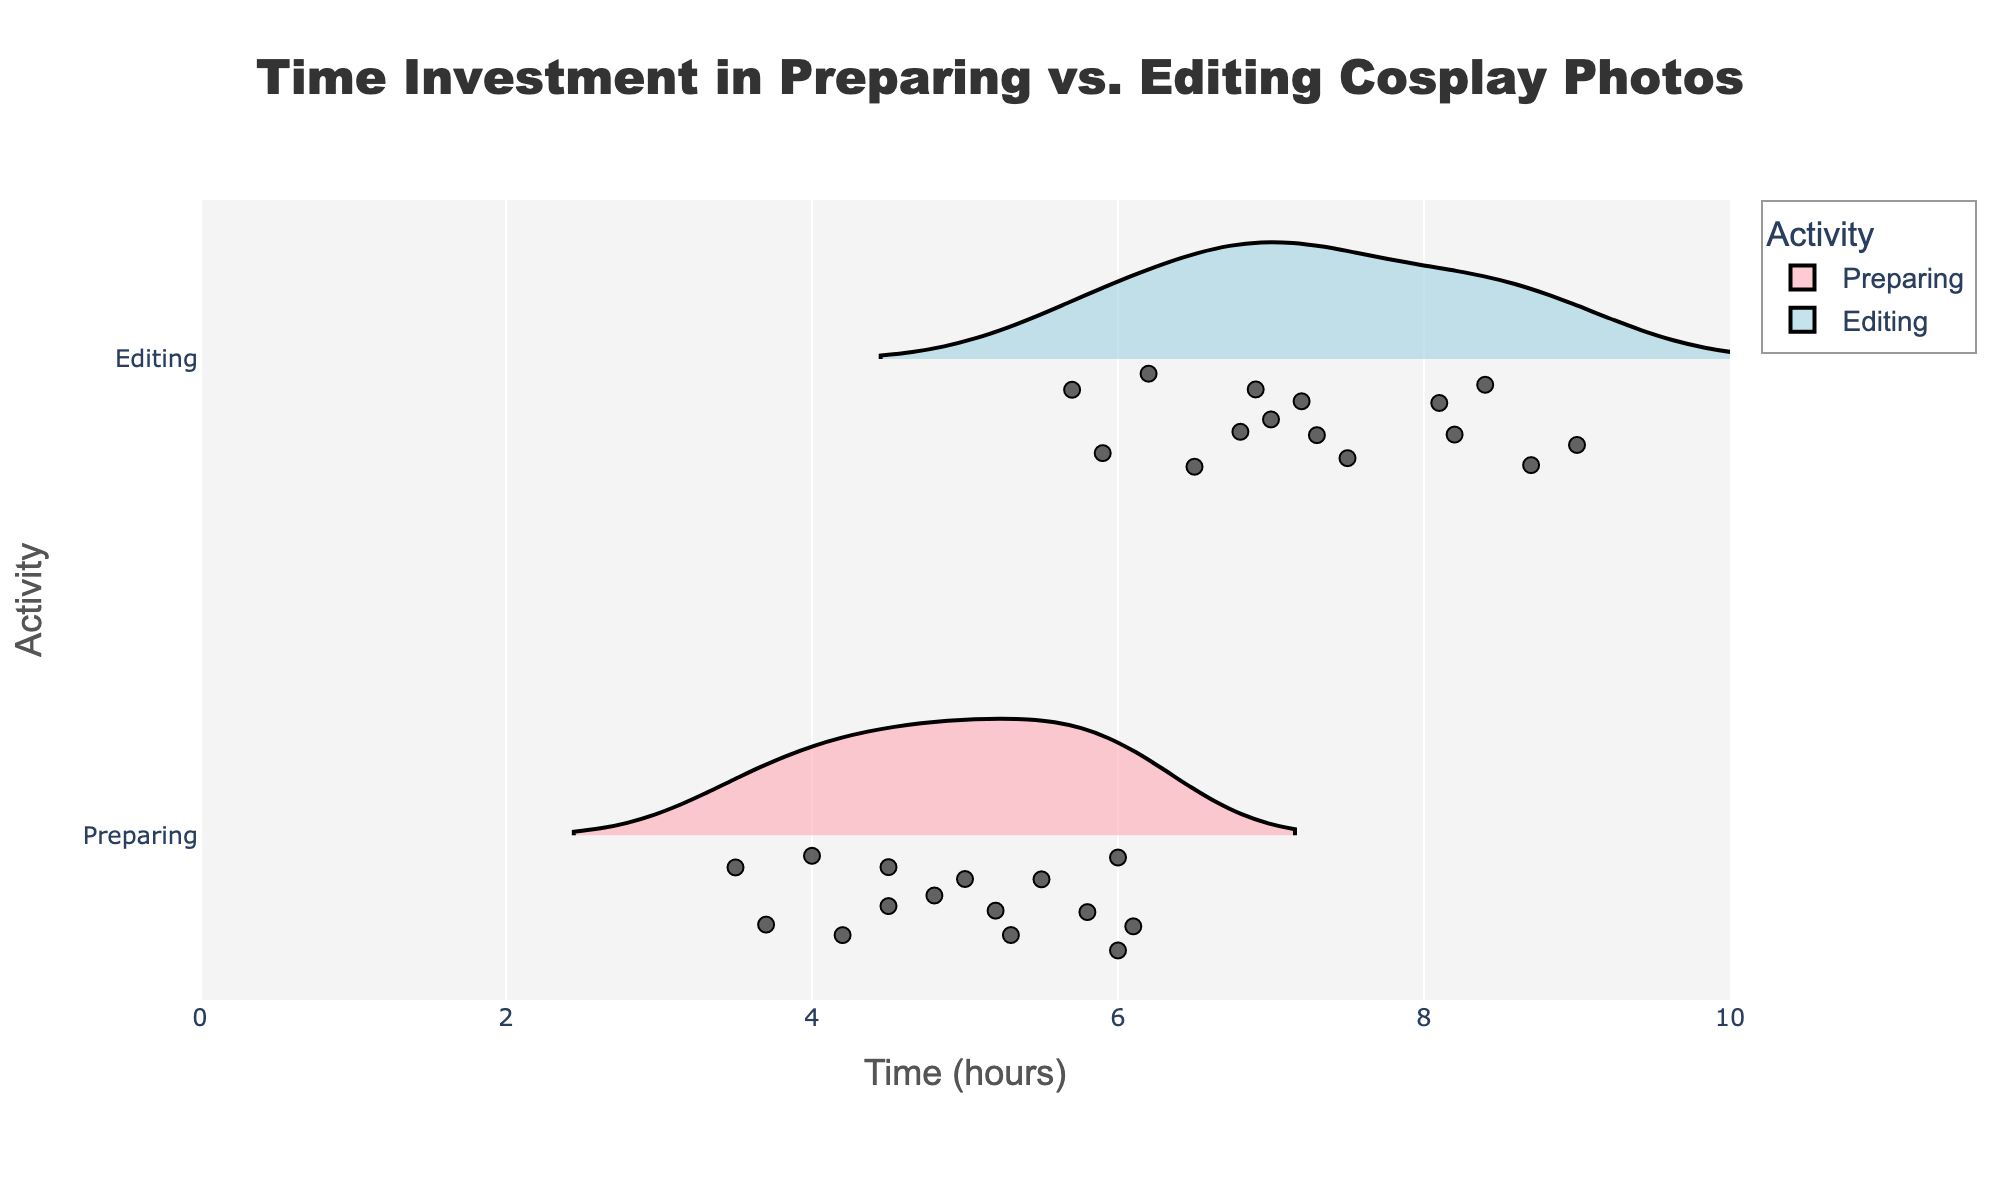What is the title of the figure? The title is displayed at the top-center of the figure and reads "Time Investment in Preparing vs. Editing Cosplay Photos."
Answer: Time Investment in Preparing vs. Editing Cosplay Photos How many activities are compared in the figure? There are two activities compared in the figure, which can be identified from the y-axis labels: ‘Preparing’ and ‘Editing.’
Answer: 2 Which activity tends to require more time investment according to the figure? By comparing the distribution of times, it can be seen that ‘Editing’ tends to have a larger spread and generally higher values compared to ‘Preparing’.
Answer: Editing What is the approximate range of time spent on preparing photos? The horizontal axis shows that the time spent on preparing photos ranges from about 3.5 hours to 6.1 hours.
Answer: 3.5 to 6.1 hours Who invests the most time in editing photos? By examining the data point distribution on the ‘Editing’ side, it's clear that Nicole Marie Jean spends the most time editing photos, with 8.7 hours.
Answer: Nicole Marie Jean What is the median time spent on preparing photos? The median can be estimated by finding the value that splits the violin plot for 'Preparing' in half. The median time for preparing photos appears to be around 5.0 hours.
Answer: 5.0 hours Who invests the least time in preparing photos, and how much time do they spend? By looking at the lowest data points on the ‘Preparing’ side, Kamui Cosplay spends the least time on preparing photos with 3.5 hours.
Answer: Kamui Cosplay, 3.5 hours Compare the upper quartile of time spent on preparing and editing photos. Which one is higher? The upper quartile can be seen near the top of each violin plot bulge. It's higher for 'Editing', which approximately reaches around 8.2 hours, compared to 'Preparing', which is around 6.0 hours.
Answer: Editing Which activity shows more data points below the mean time investment? By observing the violin plots, 'Editing' shows more points below its mean time (which looks around 7.0 hours) compared to 'Preparing', which centers near 5.0 hours.
Answer: Editing What is the difference between the maximum time spent on preparing and editing photos? The maximum time for preparing photos is 6.1 hours by Nicole Marie Jean, and editing is 9.0 hours by Alodia Gosiengfiao, resulting in a difference of 9.0 - 6.1 = 2.9 hours.
Answer: 2.9 hours 